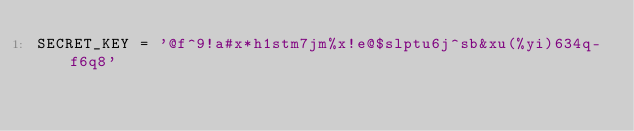Convert code to text. <code><loc_0><loc_0><loc_500><loc_500><_Python_>SECRET_KEY = '@f^9!a#x*h1stm7jm%x!e@$slptu6j^sb&xu(%yi)634q-f6q8'
</code> 